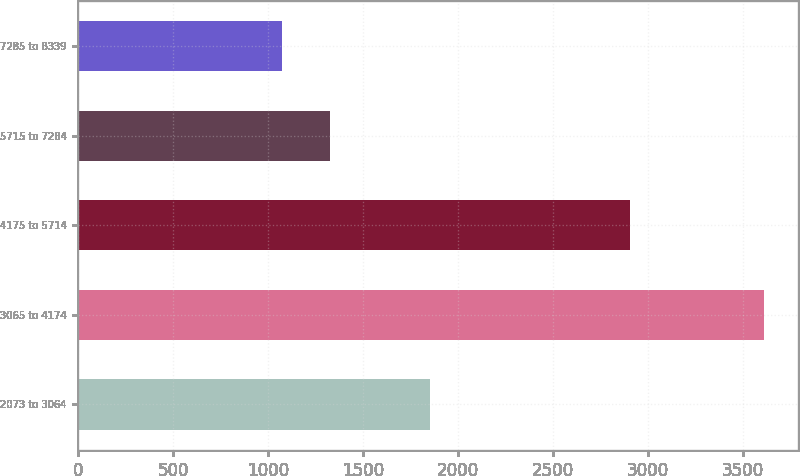Convert chart. <chart><loc_0><loc_0><loc_500><loc_500><bar_chart><fcel>2073 to 3064<fcel>3065 to 4174<fcel>4175 to 5714<fcel>5715 to 7284<fcel>7285 to 8339<nl><fcel>1854<fcel>3612<fcel>2908<fcel>1326<fcel>1072<nl></chart> 